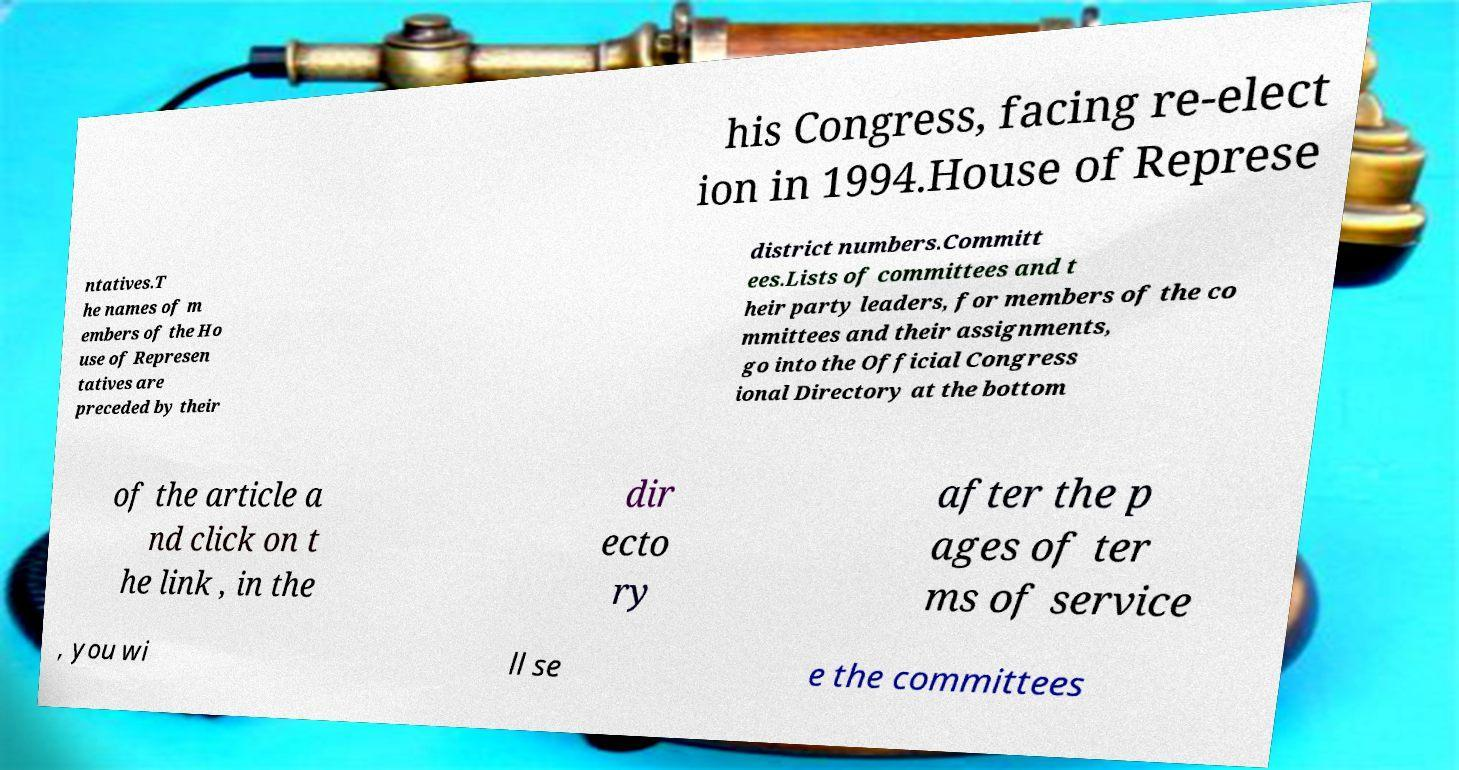Please read and relay the text visible in this image. What does it say? his Congress, facing re-elect ion in 1994.House of Represe ntatives.T he names of m embers of the Ho use of Represen tatives are preceded by their district numbers.Committ ees.Lists of committees and t heir party leaders, for members of the co mmittees and their assignments, go into the Official Congress ional Directory at the bottom of the article a nd click on t he link , in the dir ecto ry after the p ages of ter ms of service , you wi ll se e the committees 